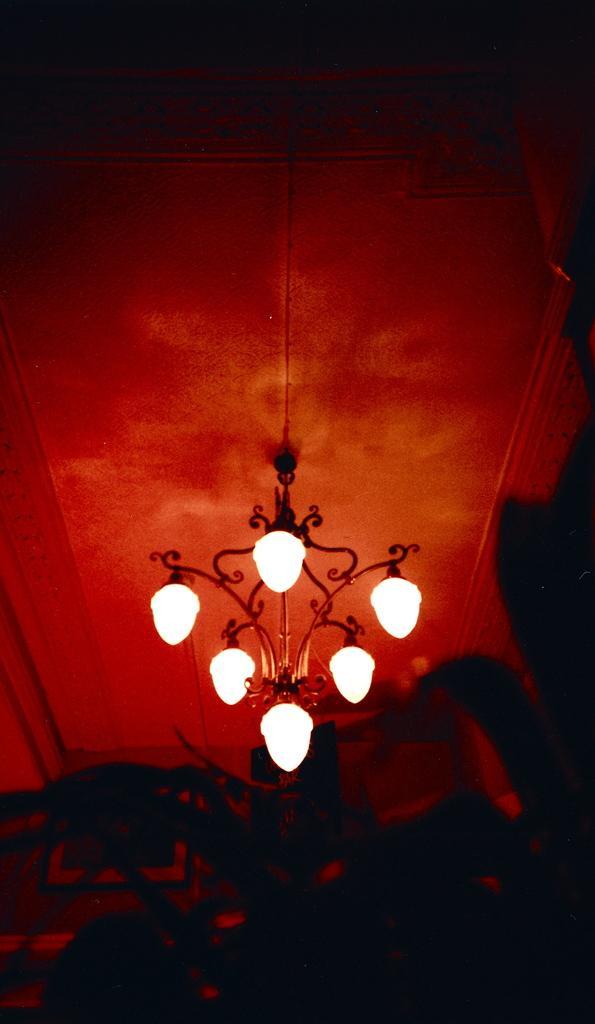In one or two sentences, can you explain what this image depicts? Here we can see a blown chandelier at the ceiling. 